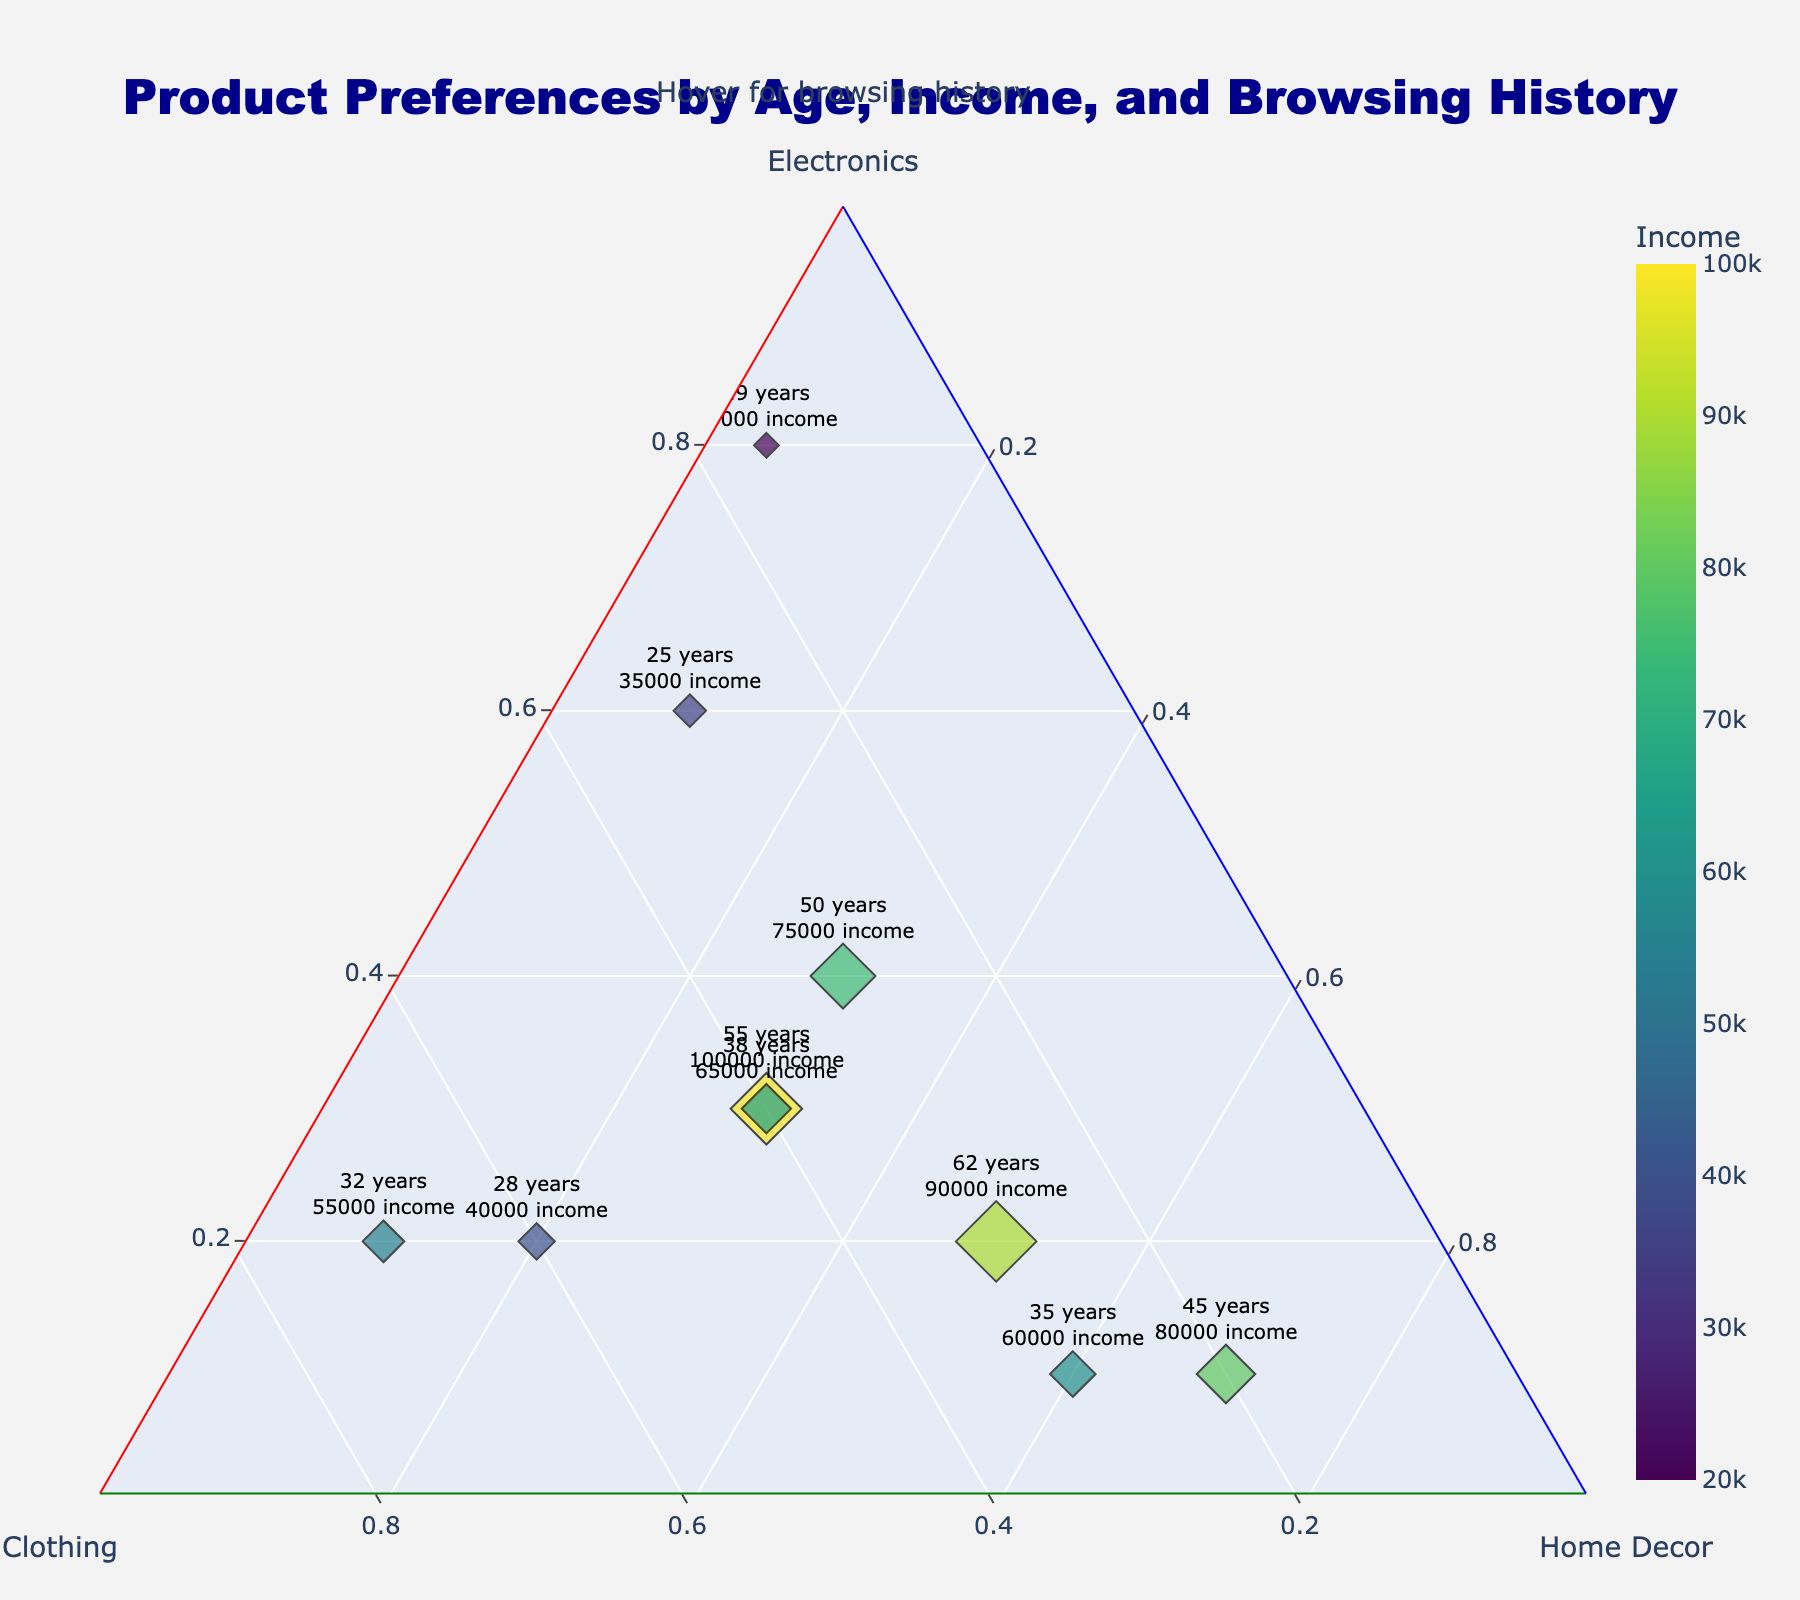How many data points are displayed in the figure? The figure shows 10 markers, each representing a data point corresponding to a customer.
Answer: 10 What axes are labeled in the ternary plot? The ternary plot has labels for three axes: Electronics, Clothing, and Home Decor. These labels are aligned along the edges of the triangular plot.
Answer: Electronics, Clothing, Home Decor Which age group exhibits the highest preference for Electronics? By observing the marker closest to the Electronics vertex, the 19-year-old with an 80% preference for Electronics stands out.
Answer: 19 years old What is the marker color indicating? The marker color represents the income level, with a color gradient indicating varying income amounts. Higher incomes use warmer colors.
Answer: Income level Which data point has the highest income, and what browsing history does it have? The marker with the highest color intensity (brightest) indicates the highest income. The point for a 55-year-old (income $100,000) interests in Luxury lifestyle blogs.
Answer: 55 years old, Luxury lifestyle blogs Between Electronics and Home Decor, which product category is preferred by the 32-year-old? The 32-year-old has markers showing higher values closer to the Clothing vertex, but between Electronics (20%) and Home Decor (10%), Electronics is preferred.
Answer: Electronics What does the marker size represent, and how is it visually differentiated? Marker size is proportional to the age of the customer. The size differences let us visually gauge the customers' ages—the larger the marker, the older the customer.
Answer: Age Which browsing history correlates with a 60% preference for Home Decor? A marker showing about a 0.6 value along the Home Decor axis is for a 35-year-old who visits Food and recipe sites.
Answer: Food and recipe sites Compare the Home Decor preferences between the 38-year-old and 62-year-old. Who prefers it more? The 62-year-old has a preference of 50% while the 38-year-old shows 30%, making the 62-year-old's preference higher.
Answer: 62 years old Considering both browsing history and preferences, which two customers have similar preferences across all product categories? The 55-year-old and the 38-year-old both show (0.3, 0.4, 0.3) for Electronics, Clothing, Home Decor. They browse different websites (Luxury vs. Parenting) but have similar preferences.
Answer: 55 years old and 38 years old 